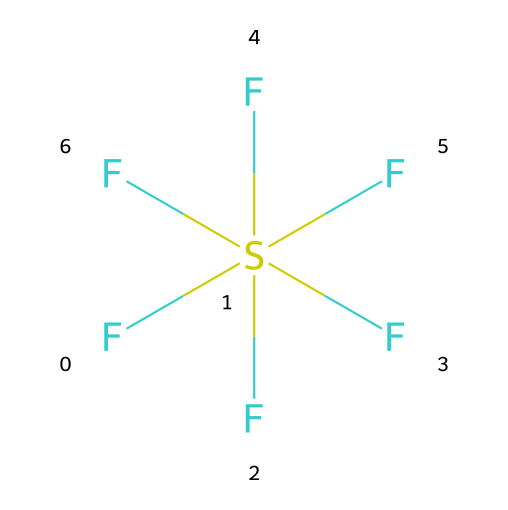how many fluorine atoms are in sulfur hexafluoride? The chemical structure shows that sulfur hexafluoride has a central sulfur atom (S) with six fluorine atoms (F) directly bonded to it. Counting the fluorine symbols in the SMILES representation confirms that there are six fluorine atoms.
Answer: six what is the central atom in the structure? In the SMILES representation, the sulfur atom (S) is surrounded by six fluorine atoms, which indicates that it is the central atom in this compound.
Answer: sulfur how many bonds are formed between sulfur and fluorine? Each fluorine atom is bonded to the sulfur atom, and there are six fluorine atoms present. Therefore, the number of bonds formed is six, as each F is connected to the S by a single bond.
Answer: six is sulfur hexafluoride a polar or nonpolar molecule? Given that the molecule has a symmetrical structure with all identical bonds and no net dipole moment, it is considered nonpolar. Therefore, sulfur hexafluoride has an even distribution of charge across its structure.
Answer: nonpolar what type of bonding is present in sulfur hexafluoride? The chemical bonds between sulfur and fluorine in sulfur hexafluoride are characterized as covalent bonds. Covalent bonding occurs when two nonmetals share electrons, in this case, between sulfur and fluorine.
Answer: covalent does sulfur hexafluoride have hypervalence? Yes, sulfur hexafluoride exhibits hypervalence because the central sulfur atom is surrounded by more than four bonds (specifically six), which exceeds the typical valence shell electron count for nonmetals, allowing for expanded octets.
Answer: yes what is the hybridization of the sulfur atom in sulfur hexafluoride? The sulfur atom in sulfur hexafluoride uses sp3d2 hybridization, which corresponds with it forming six equivalent bonds with the surrounding fluorine atoms, indicating an arrangement that accommodates six groups around the sulfur atom.
Answer: sp3d2 